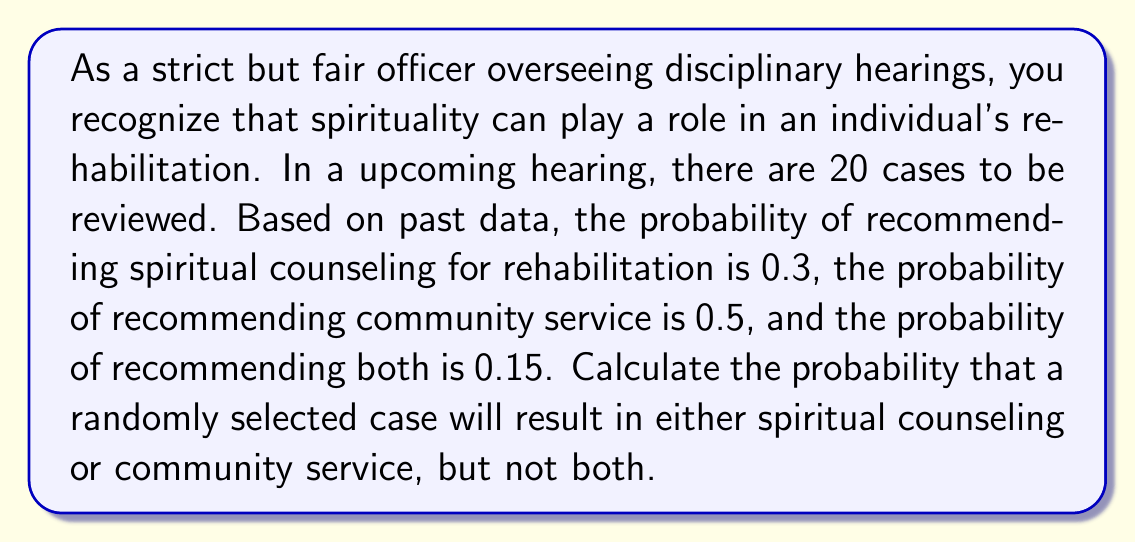Show me your answer to this math problem. To solve this problem, we'll use the concept of probability and set theory. Let's break it down step by step:

1. Define our events:
   $A$ = event of recommending spiritual counseling
   $B$ = event of recommending community service

2. Given probabilities:
   $P(A) = 0.3$
   $P(B) = 0.5$
   $P(A \cap B) = 0.15$ (probability of both occurring)

3. We want to find $P(A \cup B) - P(A \cap B)$, which represents the probability of either A or B occurring, but not both.

4. To find $P(A \cup B)$, we use the addition rule of probability:
   $P(A \cup B) = P(A) + P(B) - P(A \cap B)$

5. Substituting the given values:
   $P(A \cup B) = 0.3 + 0.5 - 0.15 = 0.65$

6. Now, we subtract $P(A \cap B)$ to exclude cases where both occur:
   $P(\text{either A or B, but not both}) = P(A \cup B) - P(A \cap B)$
   $= 0.65 - 0.15 = 0.5$

Therefore, the probability that a randomly selected case will result in either spiritual counseling or community service, but not both, is 0.5 or 50%.
Answer: $0.5$ or $50\%$ 